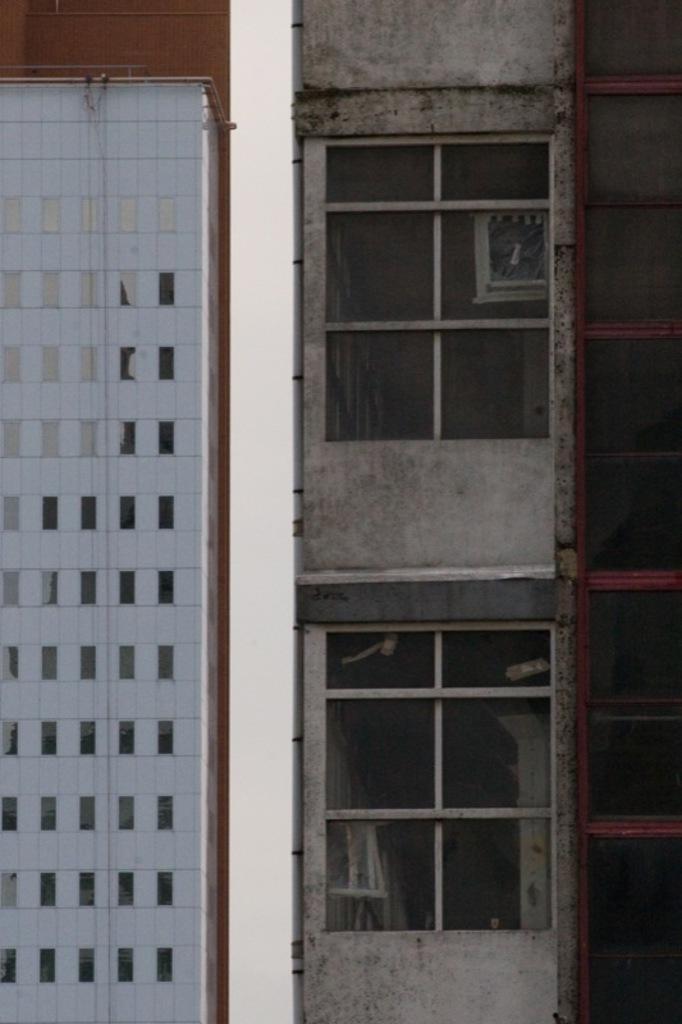In one or two sentences, can you explain what this image depicts? In this picture we can see buildings with windows. 